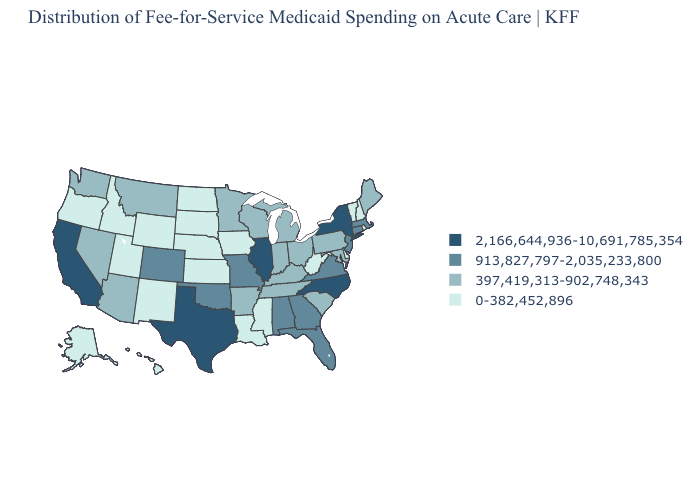Does Arkansas have the lowest value in the USA?
Give a very brief answer. No. Name the states that have a value in the range 0-382,452,896?
Concise answer only. Alaska, Delaware, Hawaii, Idaho, Iowa, Kansas, Louisiana, Mississippi, Nebraska, New Hampshire, New Mexico, North Dakota, Oregon, Rhode Island, South Dakota, Utah, Vermont, West Virginia, Wyoming. Name the states that have a value in the range 0-382,452,896?
Concise answer only. Alaska, Delaware, Hawaii, Idaho, Iowa, Kansas, Louisiana, Mississippi, Nebraska, New Hampshire, New Mexico, North Dakota, Oregon, Rhode Island, South Dakota, Utah, Vermont, West Virginia, Wyoming. Does North Carolina have the highest value in the USA?
Answer briefly. Yes. Does Michigan have the highest value in the USA?
Keep it brief. No. Name the states that have a value in the range 397,419,313-902,748,343?
Write a very short answer. Arizona, Arkansas, Indiana, Kentucky, Maine, Maryland, Michigan, Minnesota, Montana, Nevada, Ohio, Pennsylvania, South Carolina, Tennessee, Washington, Wisconsin. What is the value of South Carolina?
Write a very short answer. 397,419,313-902,748,343. Does the first symbol in the legend represent the smallest category?
Short answer required. No. Which states hav the highest value in the West?
Answer briefly. California. Does Vermont have the lowest value in the USA?
Short answer required. Yes. Does Alaska have the same value as Maryland?
Quick response, please. No. What is the value of Arizona?
Quick response, please. 397,419,313-902,748,343. What is the value of Texas?
Write a very short answer. 2,166,644,936-10,691,785,354. 